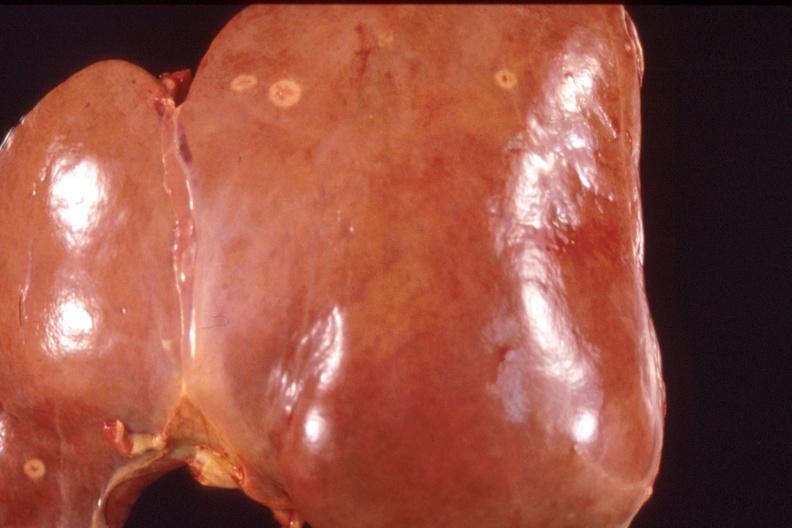s right side atresia present?
Answer the question using a single word or phrase. No 